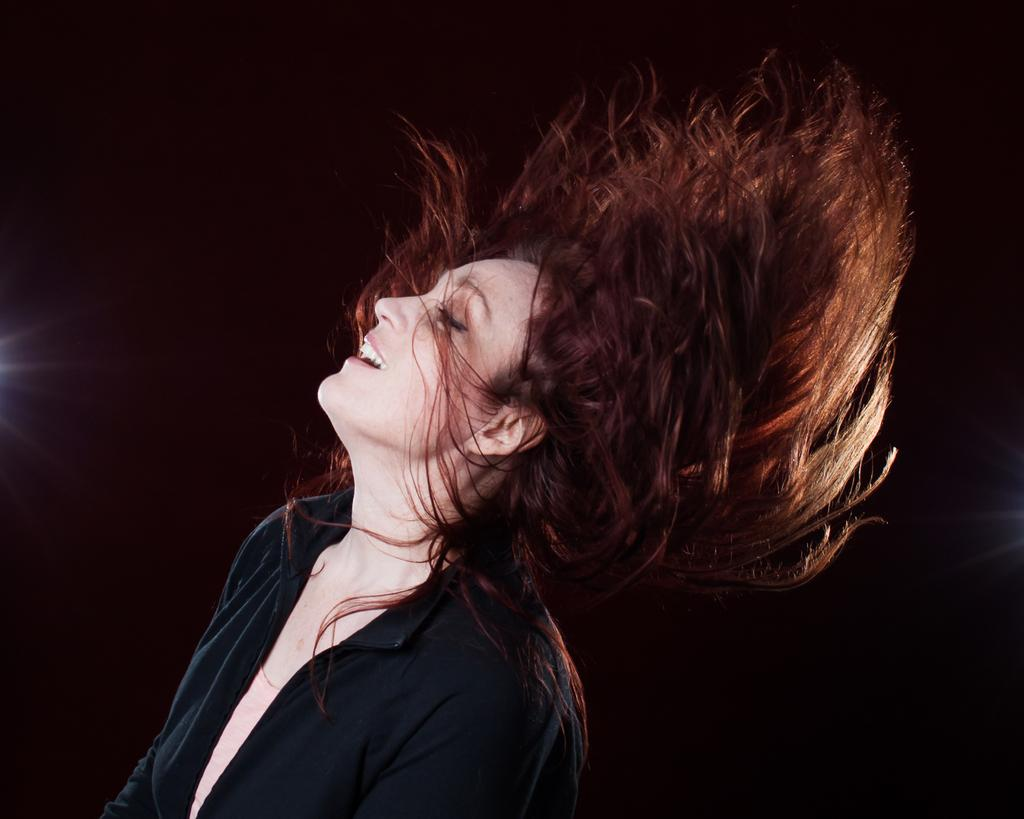What is the main subject of the picture? The main subject of the picture is a woman. What is the woman wearing in the image? The woman is wearing a black shirt. What type of reaction can be seen in the lunchroom in the image? There is no lunchroom present in the image, and therefore no reactions can be observed. 